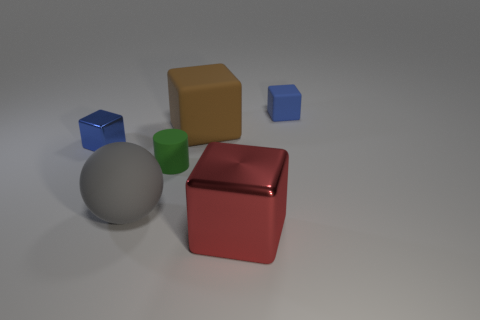Is there a tiny blue shiny cube to the right of the big block in front of the metal block to the left of the tiny green rubber thing? Upon close inspection of the scene, it's clear that the tiny blue cube indeed does not situate to the right of the large beige block. Instead, the blue cube is on the right side of the image and is smaller in comparison to the two larger cubes, one in red and the other in beige, which dominate the central part of the image. There is also a sizable metallic sphere and a smaller green cylinder to the right of the beige cube, but they do not affect the position of the blue cube in question. 